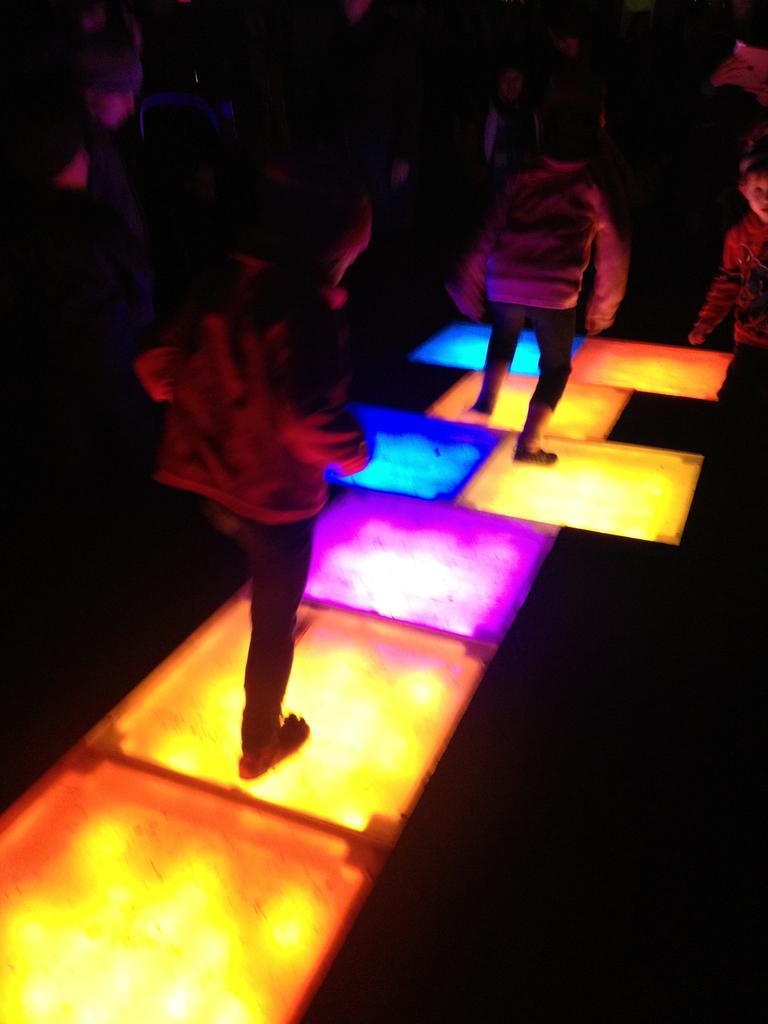What is the main feature of the floor in the image? The main feature of the floor in the image is that it is a lighting floor. How many people are standing on the lighting floor? There are people standing on the lighting floor, but the exact number is not specified. Can you describe the girl's position in the image? There is a girl standing on the side in the image. What appliance is the girl using on her journey in the image? There is no appliance or journey mentioned in the image; it only shows people standing on a lighting floor and a girl standing on the side. 